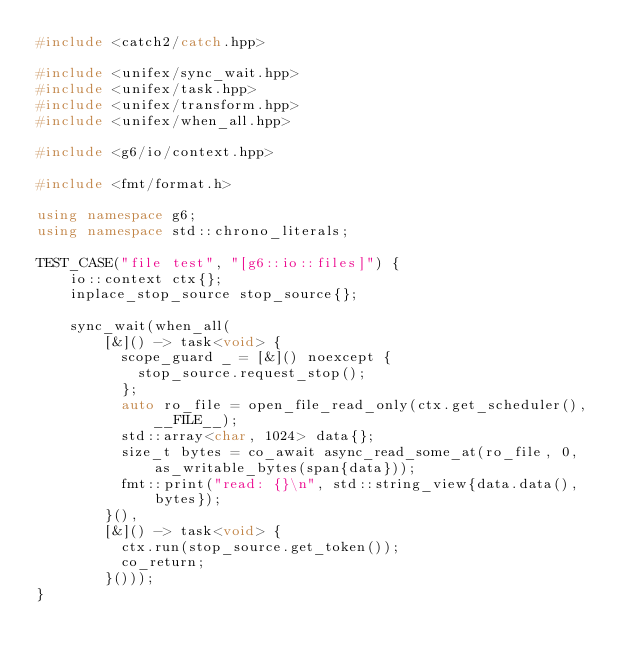<code> <loc_0><loc_0><loc_500><loc_500><_C++_>#include <catch2/catch.hpp>

#include <unifex/sync_wait.hpp>
#include <unifex/task.hpp>
#include <unifex/transform.hpp>
#include <unifex/when_all.hpp>

#include <g6/io/context.hpp>

#include <fmt/format.h>

using namespace g6;
using namespace std::chrono_literals;

TEST_CASE("file test", "[g6::io::files]") {
    io::context ctx{};
    inplace_stop_source stop_source{};

    sync_wait(when_all(
        [&]() -> task<void> {
          scope_guard _ = [&]() noexcept {
            stop_source.request_stop();
          };
          auto ro_file = open_file_read_only(ctx.get_scheduler(), __FILE__);
          std::array<char, 1024> data{};
          size_t bytes = co_await async_read_some_at(ro_file, 0, as_writable_bytes(span{data}));
          fmt::print("read: {}\n", std::string_view{data.data(), bytes});
        }(),
        [&]() -> task<void> {
          ctx.run(stop_source.get_token());
          co_return;
        }()));
}
</code> 